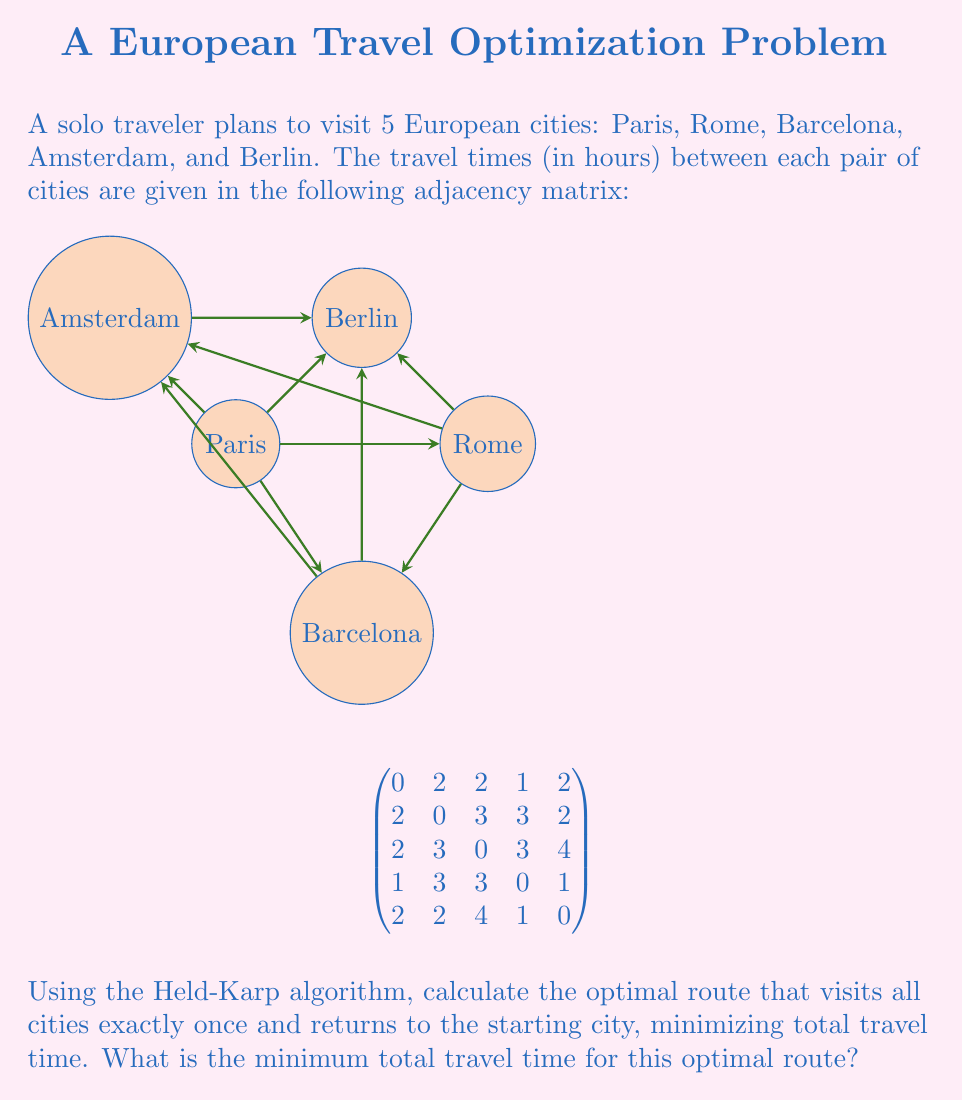What is the answer to this math problem? To solve this problem using the Held-Karp algorithm, we'll follow these steps:

1) Initialize the base cases: For each city j, calculate the cost of going from the starting city (let's choose Paris as city 0) to j:
   $C(\{j\}, j) = \text{matrix}[0][j]$

2) For subsets S of size 2 to n-1:
   For each j in S:
      $C(S, j) = \min_{i \in S, i \neq j} \{C(S - \{j\}, i) + \text{matrix}[i][j]\}$

3) Find the optimal cost:
   $\text{optimal\_cost} = \min_{j \neq 0} \{C(\text{all cities except 0}, j) + \text{matrix}[j][0]\}$

Let's apply this to our problem:

Step 1: Base cases
$C(\{1\}, 1) = 2$, $C(\{2\}, 2) = 2$, $C(\{3\}, 3) = 1$, $C(\{4\}, 4) = 2$

Step 2: Building up subsets
For S = {1,2}: $C(\{1,2\}, 1) = 5$, $C(\{1,2\}, 2) = 4$
For S = {1,3}: $C(\{1,3\}, 1) = 3$, $C(\{1,3\}, 3) = 3$
For S = {1,4}: $C(\{1,4\}, 1) = 4$, $C(\{1,4\}, 4) = 3$
For S = {2,3}: $C(\{2,3\}, 2) = 5$, $C(\{2,3\}, 3) = 4$
For S = {2,4}: $C(\{2,4\}, 2) = 4$, $C(\{2,4\}, 4) = 4$
For S = {3,4}: $C(\{3,4\}, 3) = 2$, $C(\{3,4\}, 4) = 2$

For S = {1,2,3}: $C(\{1,2,3\}, 1) = 7$, $C(\{1,2,3\}, 2) = 6$, $C(\{1,2,3\}, 3) = 6$
For S = {1,2,4}: $C(\{1,2,4\}, 1) = 6$, $C(\{1,2,4\}, 2) = 6$, $C(\{1,2,4\}, 4) = 5$
For S = {1,3,4}: $C(\{1,3,4\}, 1) = 5$, $C(\{1,3,4\}, 3) = 4$, $C(\{1,3,4\}, 4) = 4$
For S = {2,3,4}: $C(\{2,3,4\}, 2) = 6$, $C(\{2,3,4\}, 3) = 5$, $C(\{2,3,4\}, 4) = 5$

For S = {1,2,3,4}: 
$C(\{1,2,3,4\}, 1) = 8$
$C(\{1,2,3,4\}, 2) = 8$
$C(\{1,2,3,4\}, 3) = 7$
$C(\{1,2,3,4\}, 4) = 7$

Step 3: Find the optimal cost
$\text{optimal\_cost} = \min\{C(\{1,2,3,4\}, 1) + \text{matrix}[1][0],$ 
$C(\{1,2,3,4\}, 2) + \text{matrix}[2][0],$ 
$C(\{1,2,3,4\}, 3) + \text{matrix}[3][0],$ 
$C(\{1,2,3,4\}, 4) + \text{matrix}[4][0]\}$

$= \min\{8 + 2, 8 + 2, 7 + 1, 7 + 2\} = \min\{10, 10, 8, 9\} = 8$

Therefore, the minimum total travel time for the optimal route is 8 hours.
Answer: 8 hours 